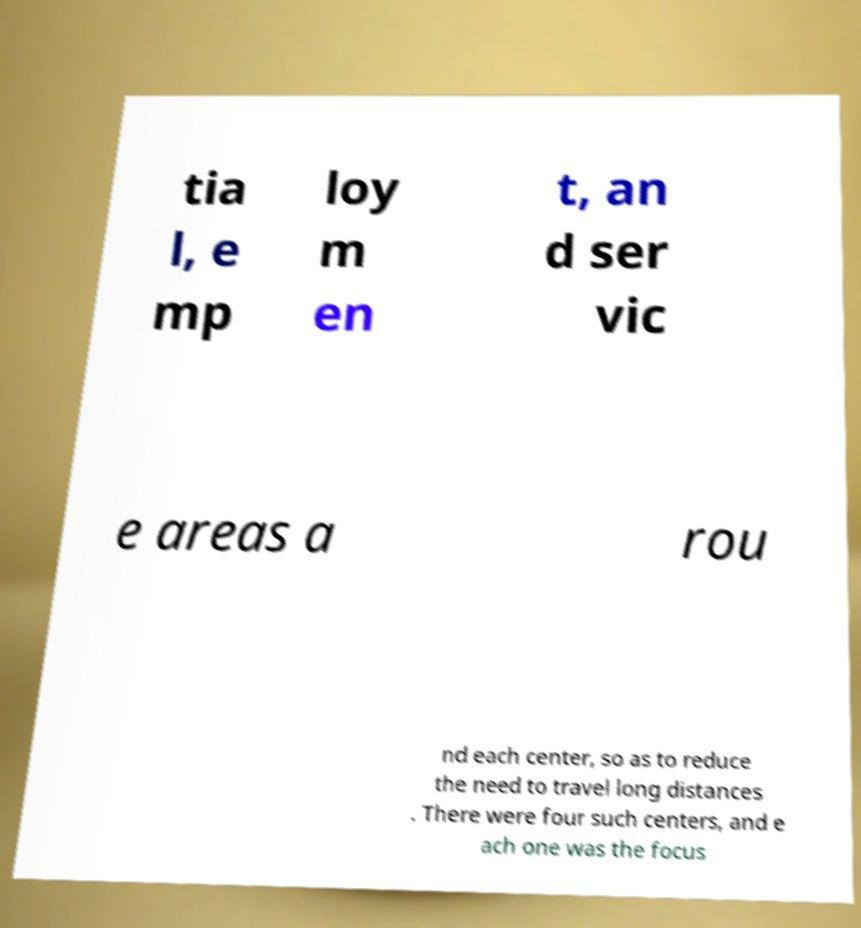There's text embedded in this image that I need extracted. Can you transcribe it verbatim? tia l, e mp loy m en t, an d ser vic e areas a rou nd each center, so as to reduce the need to travel long distances . There were four such centers, and e ach one was the focus 